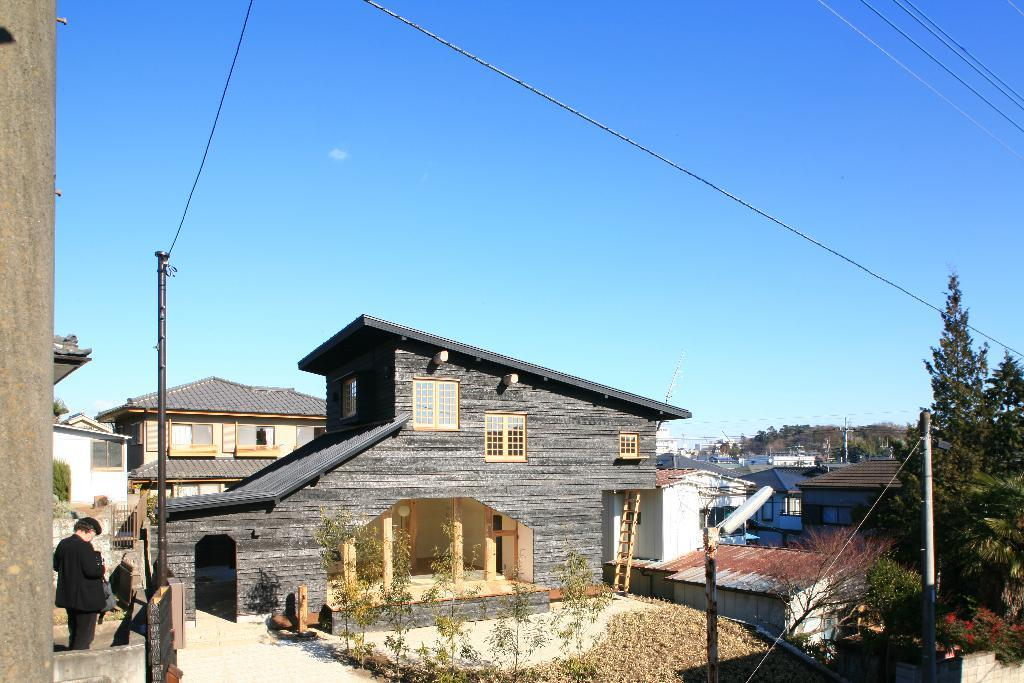Where was the image taken? The image was taken outside a city. What can be seen in the foreground of the image? There are trees, poles, buildings, dry leaves, and flowers in the foreground of the image. Is there any human presence in the image? Yes, there is a man standing in the foreground of the image. What is the weather like in the image? The sky is clear, and it is sunny in the image. What type of goldfish can be seen swimming in the image? There are no goldfish present in the image; it is taken outside a city with a man standing in the foreground. What kind of feast is being prepared in the image? There is no indication of a feast or any food preparation in the image. 